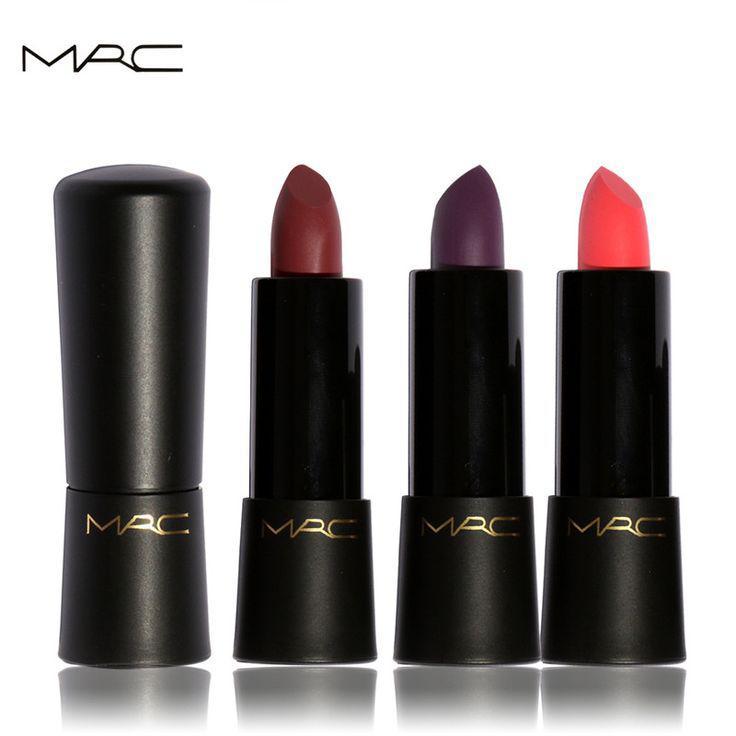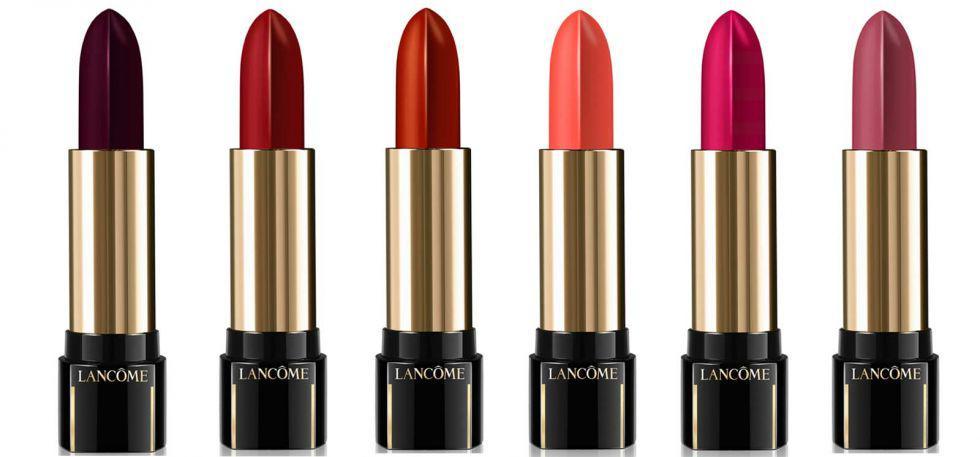The first image is the image on the left, the second image is the image on the right. Evaluate the accuracy of this statement regarding the images: "There are at least six lipsticks in the image on the right.". Is it true? Answer yes or no. Yes. The first image is the image on the left, the second image is the image on the right. For the images displayed, is the sentence "One image shows exactly five available shades of lipstick." factually correct? Answer yes or no. No. The first image is the image on the left, the second image is the image on the right. Considering the images on both sides, is "There are more lipsticks on the right than on the left image." valid? Answer yes or no. Yes. 